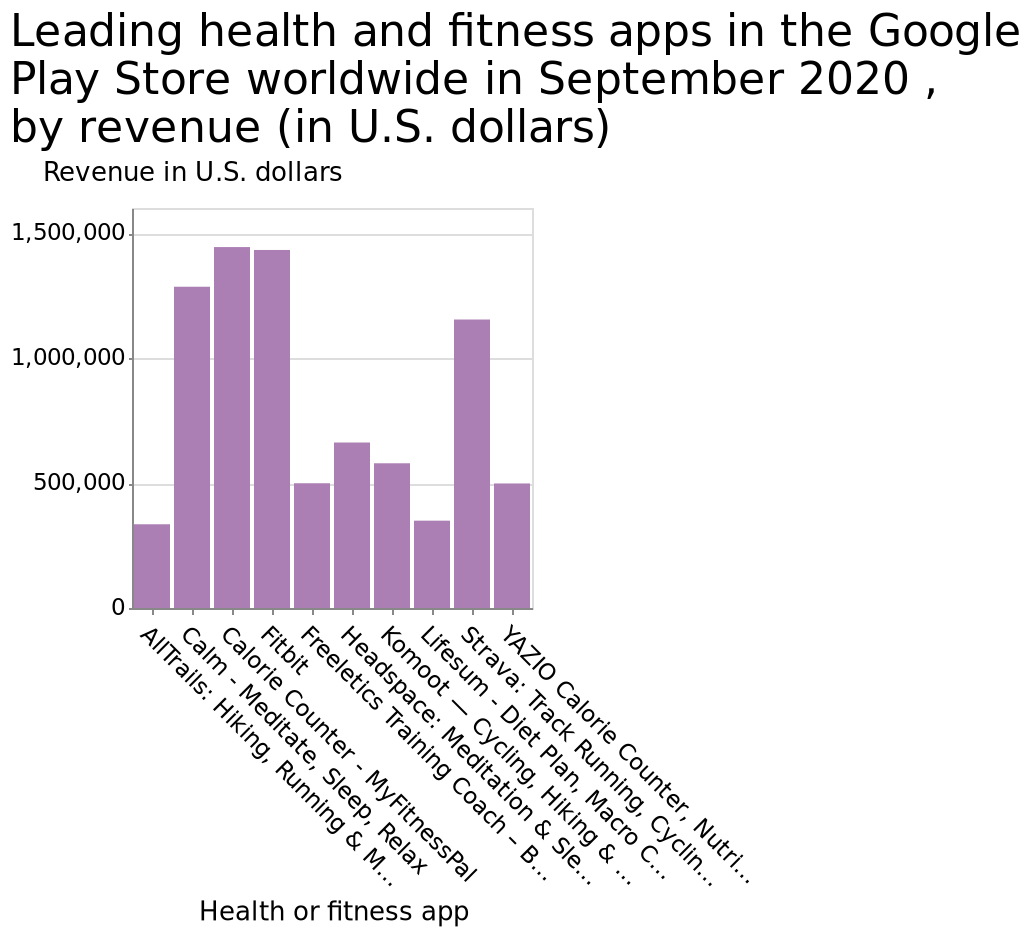<image>
Do these leading apps dominate the health and fitness app market in terms of revenue? Yes, these leading apps dominate the health and fitness app market in terms of revenue as they are generating over 1 million while the rest of the apps are not making half of that amount. Which are the four leading health and fitness apps mentioned in the figure? The four leading health and fitness apps mentioned in the figure are Calorie Counter, Fitbit, Calm, and Strava. Can you name some of the other health and fitness apps mentioned in the figure? The figure did not provide names for any other health and fitness apps apart from the four leading ones. How many health or fitness apps are represented in the revenue bar graph for September 2020?  There are multiple health or fitness apps represented on the revenue bar graph for September 2020. What is the revenue in U.S. dollars earned by the YAZIO Calorie Counter, Nutrition Diary & Diet Plan app in the Google Play Store worldwide in September 2020?  The YAZIO Calorie Counter, Nutrition Diary & Diet Plan app earned a revenue of $1,500,000 in the Google Play Store worldwide in September 2020. 